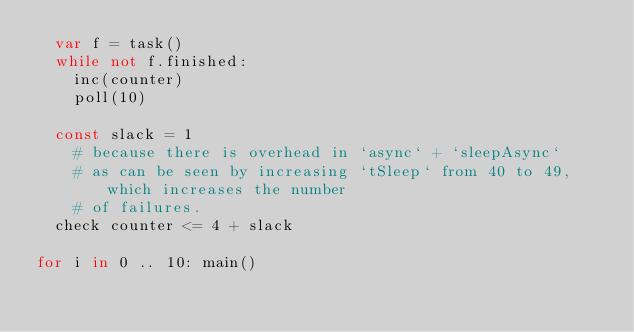Convert code to text. <code><loc_0><loc_0><loc_500><loc_500><_Nim_>  var f = task()
  while not f.finished:
    inc(counter)
    poll(10)

  const slack = 1
    # because there is overhead in `async` + `sleepAsync`
    # as can be seen by increasing `tSleep` from 40 to 49, which increases the number
    # of failures.
  check counter <= 4 + slack

for i in 0 .. 10: main()
</code> 